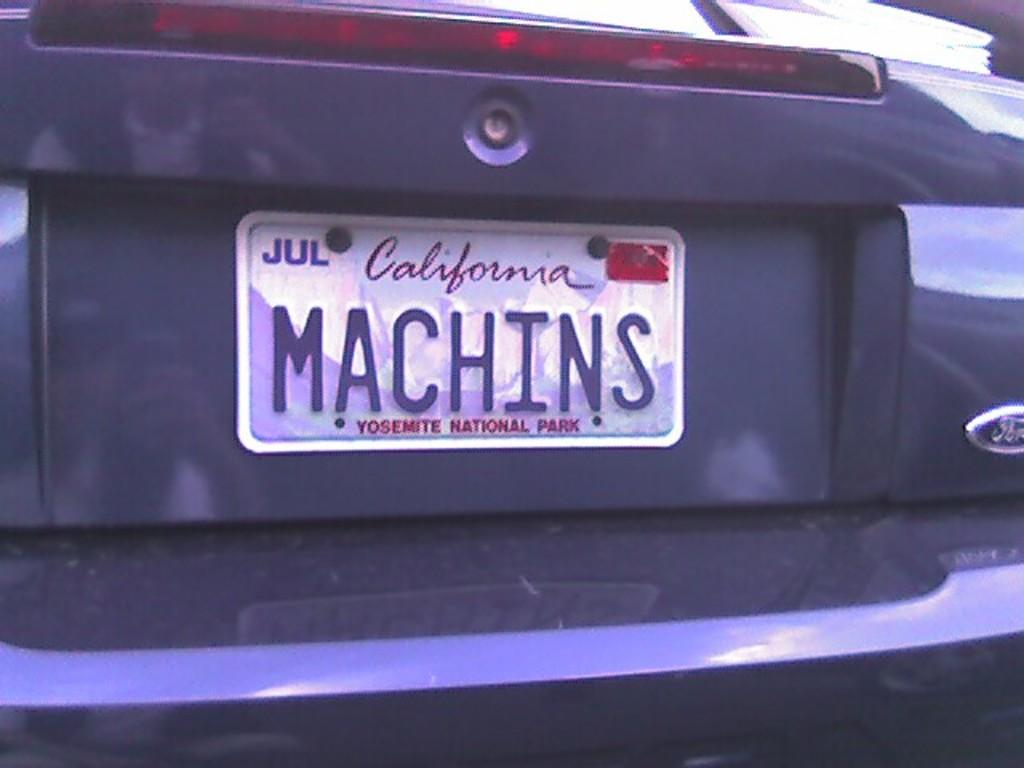Provide a one-sentence caption for the provided image. The back of a ford branded vehicle with a California state license plate. 